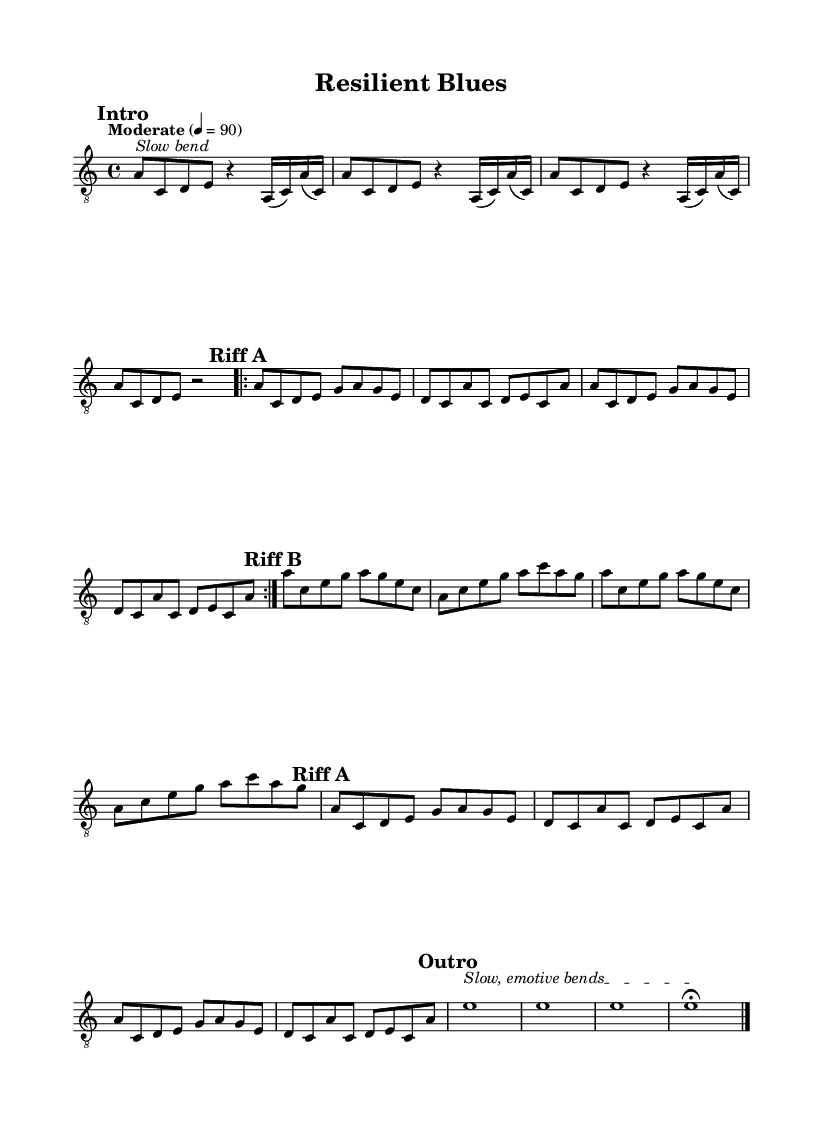What is the key signature of this music? The key signature is determined by the key noted at the beginning of the staff. Here, it is indicated as a minor, which typically corresponds to the one sharp of G major or the relative minor, A minor.
Answer: A minor What is the time signature of this music? The time signature is located at the beginning of the staff, right after the key signature. It is marked as 4/4, indicating four beats per measure and the quarter note gets one beat.
Answer: 4/4 What is the tempo marking of this music? The tempo marking is specified in words in the score. The marking indicates "Moderate" with a metronome marking of 90, denoting a moderate speed for the piece.
Answer: Moderate 90 How many times is Riff A repeated? Riff A is marked with a "repeat volta 2," indicating that it is played a total of two times before moving on to the next section.
Answer: 2 Which instrument is specified in the score? The instrument is indicated in the score's setup for specific sounds; here, it is marked as an electric guitar, which gives an electric blues sound to the music.
Answer: Electric guitar What do the markings "Slow bend" and "Slow, emotive bends" indicate about the playing style? These markings suggest performance instructions that request the guitarist to utilize slowing techniques and bending of the notes, which are common expressive techniques in electric blues, contributing to the soulful character of the riffs.
Answer: Expressive techniques What is the last note of the outro section before the fermata? The last note of the outro section is marked as an e note. This indicates a sustained tone capturing emotion, typical for a blues outro.
Answer: e 